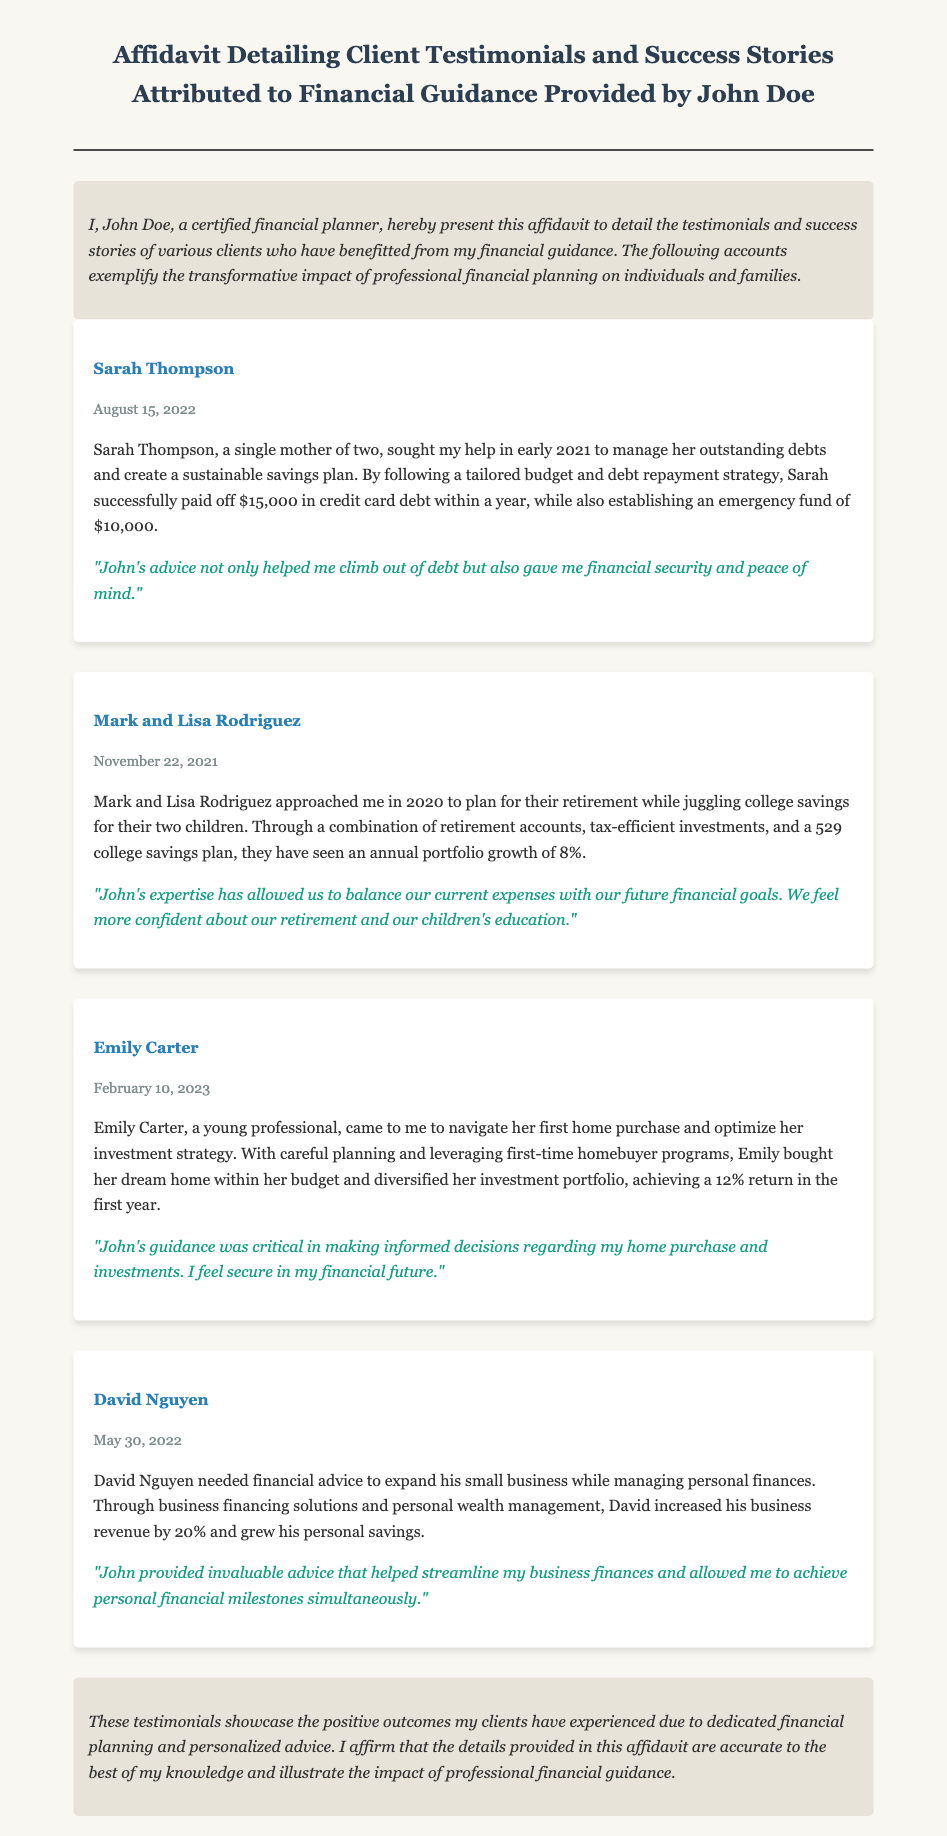What is the name of the financial planner? The financial planner's name is stated at the beginning of the affidavit.
Answer: John Doe How much credit card debt did Sarah Thompson pay off? The specific amount Sarah Thompson paid off is mentioned in her testimonial.
Answer: $15,000 What was the date of Mark and Lisa Rodriguez's testimonial? The date can be found in the testimonials section for Mark and Lisa Rodriguez.
Answer: November 22, 2021 What financial achievement did Emily Carter experience in her first year after purchasing a home? The document specifies the return on Emily's investments in the first year.
Answer: 12% What was David Nguyen's increase in business revenue percentage? This detail is provided in David's testimonial under his financial achievements.
Answer: 20% What financial solution did Mark and Lisa Rodriguez use for their children’s education? The document outlines the education savings strategy they utilized.
Answer: 529 college savings plan How much did Sarah Thompson establish as an emergency fund? This information is included in Sarah's testimonial regarding her financial milestones.
Answer: $10,000 What was the annual portfolio growth percentage mentioned for Mark and Lisa Rodriguez? The affidavit states this percentage clearly within their testimonial.
Answer: 8% What is the overall theme of the affidavit? The document summarizes the main purpose and subjects covered within it.
Answer: Client testimonials and success stories 